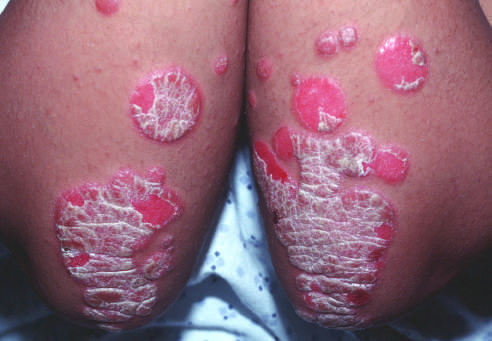re erythematous psoriatic plaques covered by silvery-white scale?
Answer the question using a single word or phrase. Yes 